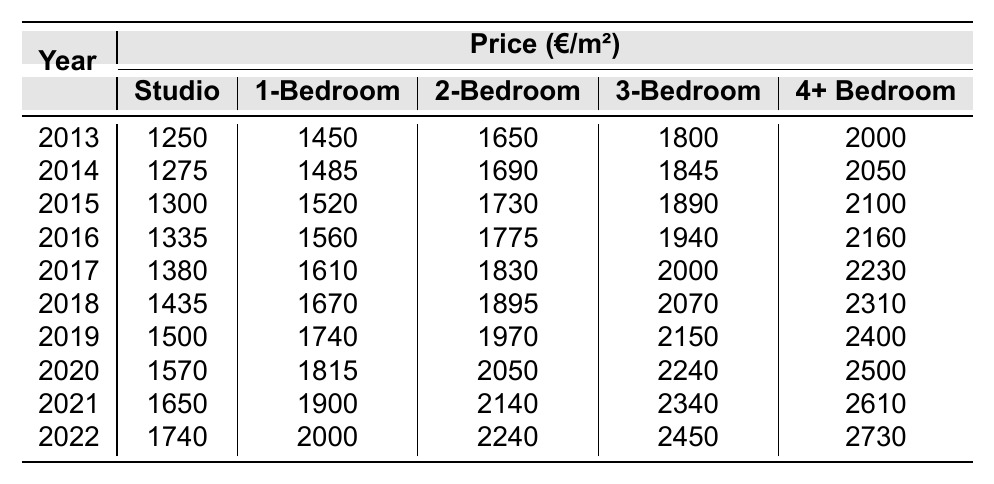What was the price per square meter for a 2-bedroom home in Belfort in 2016? In the table, if we look at the row for the year 2016, we can see the price for a 2-bedroom home is listed as 1775 €/m².
Answer: 1775 €/m² Which year saw the highest price for a studio home? By examining the years in the table for the studio prices, the row for 2022 shows the highest price at 1740 €/m² compared to previous years.
Answer: 1740 €/m² What was the difference in price per square meter between 3-bedroom homes in 2022 and 2013? From the table, the price for 3-bedroom homes in 2022 is 2450 €/m², while in 2013 it was 1800 €/m². The difference is 2450 - 1800 = 650 €/m².
Answer: 650 €/m² In which year did the price of a 1-bedroom home first exceed 1900 €/m²? Looking through the table, the price for a 1-bedroom home exceeds 1900 €/m² starting from 2021 when the price is 1900 €/m². In 2022, it's 2000 €/m².
Answer: 2021 What is the average price per square meter for a 4+ bedroom home over the last decade? To find the average, sum the prices from each year (2000 + 2050 + 2100 + 2160 + 2230 + 2310 + 2400 + 2500 + 2610 + 2730 = 23200) and divide by the number of years (10). The average price is 23200/10 = 2320 €/m².
Answer: 2320 €/m² Which home size saw the largest increase in price from 2013 to 2022? Analyzing the price changes from 2013 to 2022: Studio increased by 490 €, 1-bedroom by 550 €, 2-bedroom by 590 €, 3-bedroom by 650 €, and 4+ bedroom by 730 €. The 4+ bedroom homes saw the largest increase of 730 €.
Answer: 4+ bedroom Was there a year where the price of a studio home decreased from the previous year? Checking the annual prices, there's no instance of a decrease; all studio prices show a consistent increase from 2013 through 2022.
Answer: No What is the total price for purchasing a 2-bedroom home in Belfort for the year 2019? From the table, the price per square meter for a 2-bedroom home in 2019 is 1970 €/m². This reflects the total price calculation which depends on the assumed area of the property.
Answer: 1970 €/m² How much more expensive is a 4+ bedroom home than a studio home in 2020? In 2020, the price for a 4+ bedroom home is 2500 €/m² and for a studio, it is 1570 €/m². The difference is 2500 - 1570 = 930 €/m².
Answer: 930 €/m² What percentage increase in price did the 3-bedroom homes experience from 2014 to 2021? The price for 3-bedroom homes in 2014 is 1845 €/m², and in 2021 it is 2340 €/m². The increase is 2340 - 1845 = 495 €. The percentage increase is (495/1845) * 100 = 26.85%.
Answer: 26.85% 